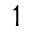Convert formula to latex. <formula><loc_0><loc_0><loc_500><loc_500>^ { 1 }</formula> 